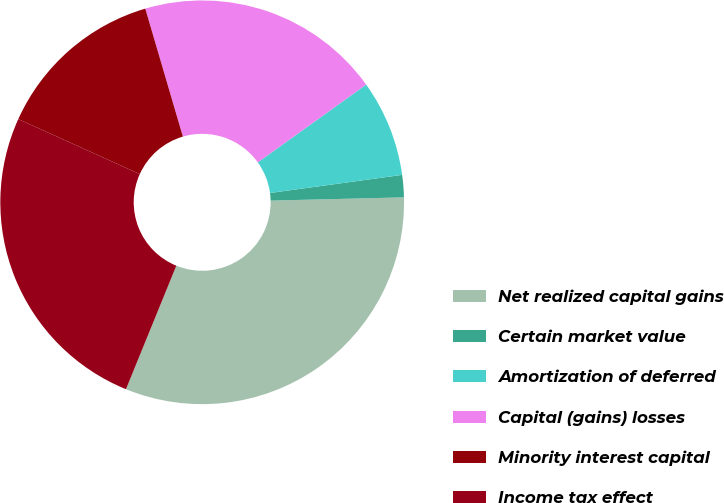Convert chart to OTSL. <chart><loc_0><loc_0><loc_500><loc_500><pie_chart><fcel>Net realized capital gains<fcel>Certain market value<fcel>Amortization of deferred<fcel>Capital (gains) losses<fcel>Minority interest capital<fcel>Income tax effect<nl><fcel>31.55%<fcel>1.78%<fcel>7.74%<fcel>19.64%<fcel>13.69%<fcel>25.6%<nl></chart> 